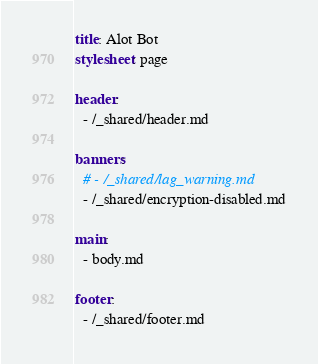Convert code to text. <code><loc_0><loc_0><loc_500><loc_500><_YAML_>title: Alot Bot
stylesheet: page

header:
  - /_shared/header.md

banners:
  # - /_shared/lag_warning.md
  - /_shared/encryption-disabled.md

main:
  - body.md

footer:
  - /_shared/footer.md
</code> 